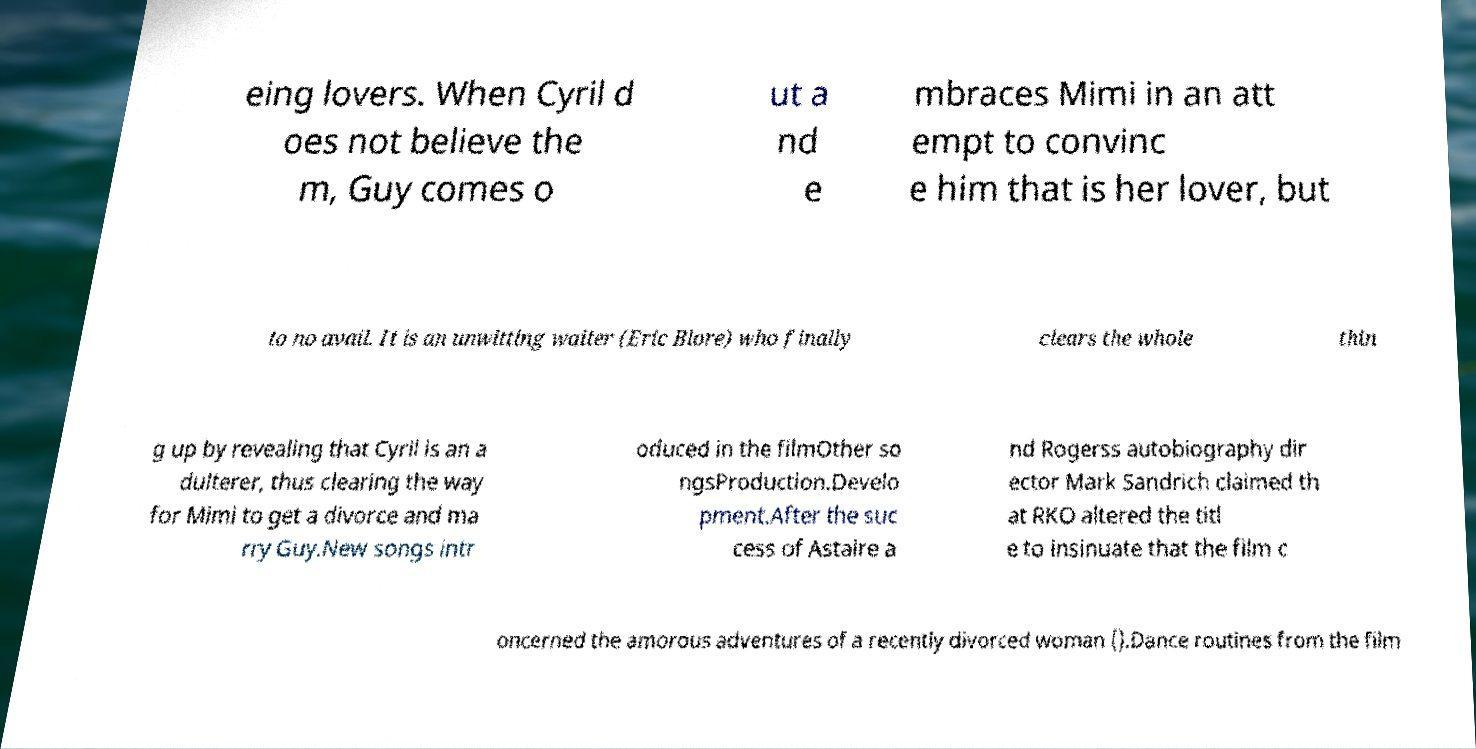I need the written content from this picture converted into text. Can you do that? eing lovers. When Cyril d oes not believe the m, Guy comes o ut a nd e mbraces Mimi in an att empt to convinc e him that is her lover, but to no avail. It is an unwitting waiter (Eric Blore) who finally clears the whole thin g up by revealing that Cyril is an a dulterer, thus clearing the way for Mimi to get a divorce and ma rry Guy.New songs intr oduced in the filmOther so ngsProduction.Develo pment.After the suc cess of Astaire a nd Rogerss autobiography dir ector Mark Sandrich claimed th at RKO altered the titl e to insinuate that the film c oncerned the amorous adventures of a recently divorced woman ().Dance routines from the film 